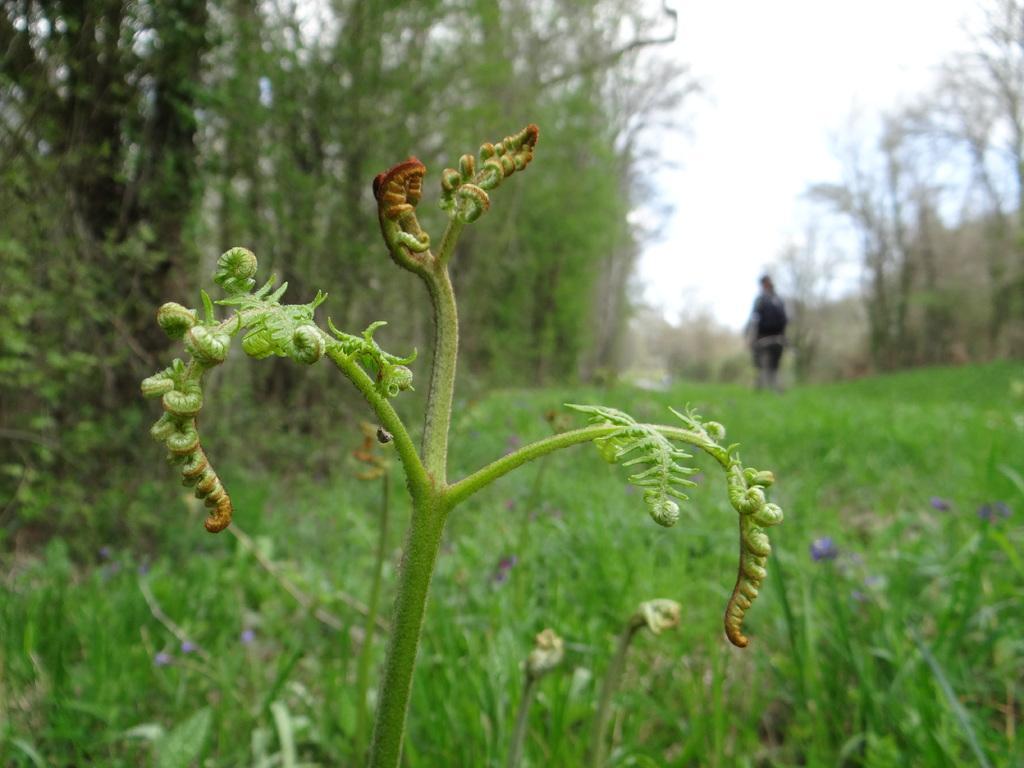Could you give a brief overview of what you see in this image? We can see plants. In the background we can see trees,person and sky. 